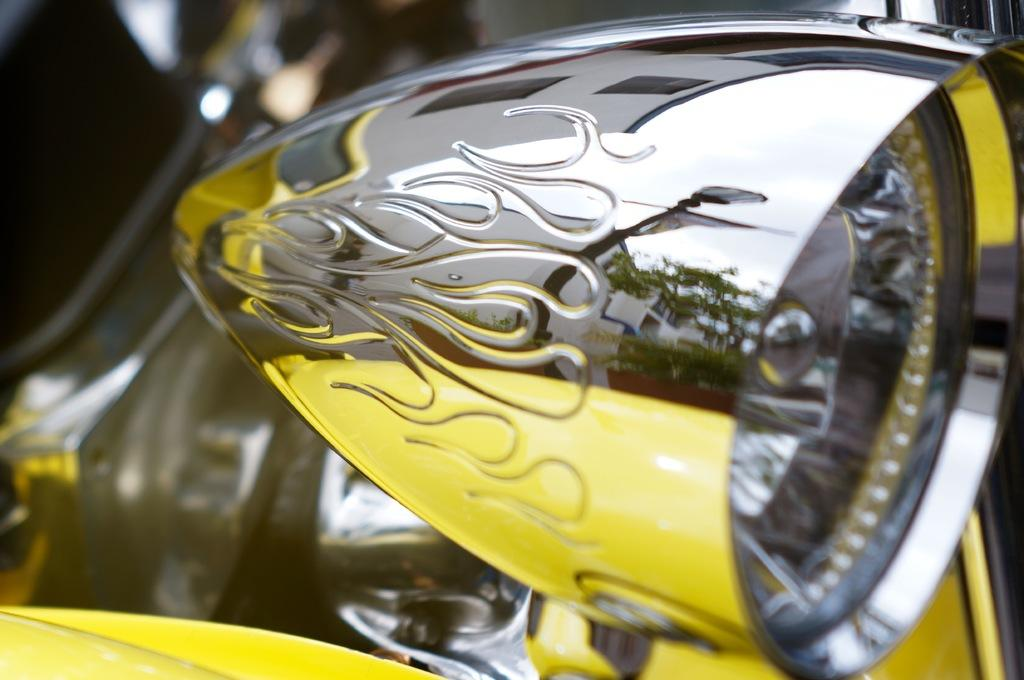What is the main subject of the image? There is a vehicle in the image. Can you describe any specific features of the vehicle? The reflection of buildings and trees is visible on the vehicle. What else is present in the image besides the vehicle? There is a light in the image. What type of vegetable is being discussed in the meeting depicted in the image? There is no meeting or vegetable present in the image; it features a vehicle with reflections of buildings and trees. Can you tell me how many ears are visible in the image? There are no ears visible in the image; it features a vehicle with reflections of buildings and trees. 